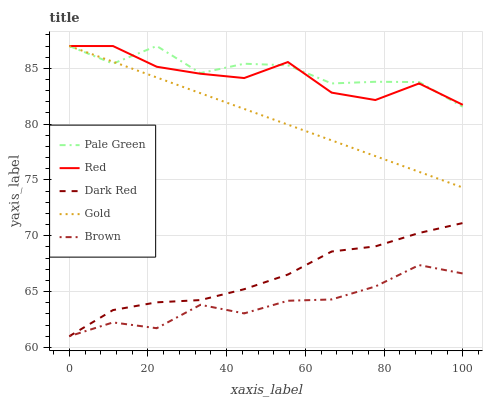Does Brown have the minimum area under the curve?
Answer yes or no. Yes. Does Pale Green have the maximum area under the curve?
Answer yes or no. Yes. Does Gold have the minimum area under the curve?
Answer yes or no. No. Does Gold have the maximum area under the curve?
Answer yes or no. No. Is Gold the smoothest?
Answer yes or no. Yes. Is Pale Green the roughest?
Answer yes or no. Yes. Is Pale Green the smoothest?
Answer yes or no. No. Is Gold the roughest?
Answer yes or no. No. Does Dark Red have the lowest value?
Answer yes or no. Yes. Does Pale Green have the lowest value?
Answer yes or no. No. Does Red have the highest value?
Answer yes or no. Yes. Does Brown have the highest value?
Answer yes or no. No. Is Brown less than Gold?
Answer yes or no. Yes. Is Gold greater than Dark Red?
Answer yes or no. Yes. Does Pale Green intersect Gold?
Answer yes or no. Yes. Is Pale Green less than Gold?
Answer yes or no. No. Is Pale Green greater than Gold?
Answer yes or no. No. Does Brown intersect Gold?
Answer yes or no. No. 